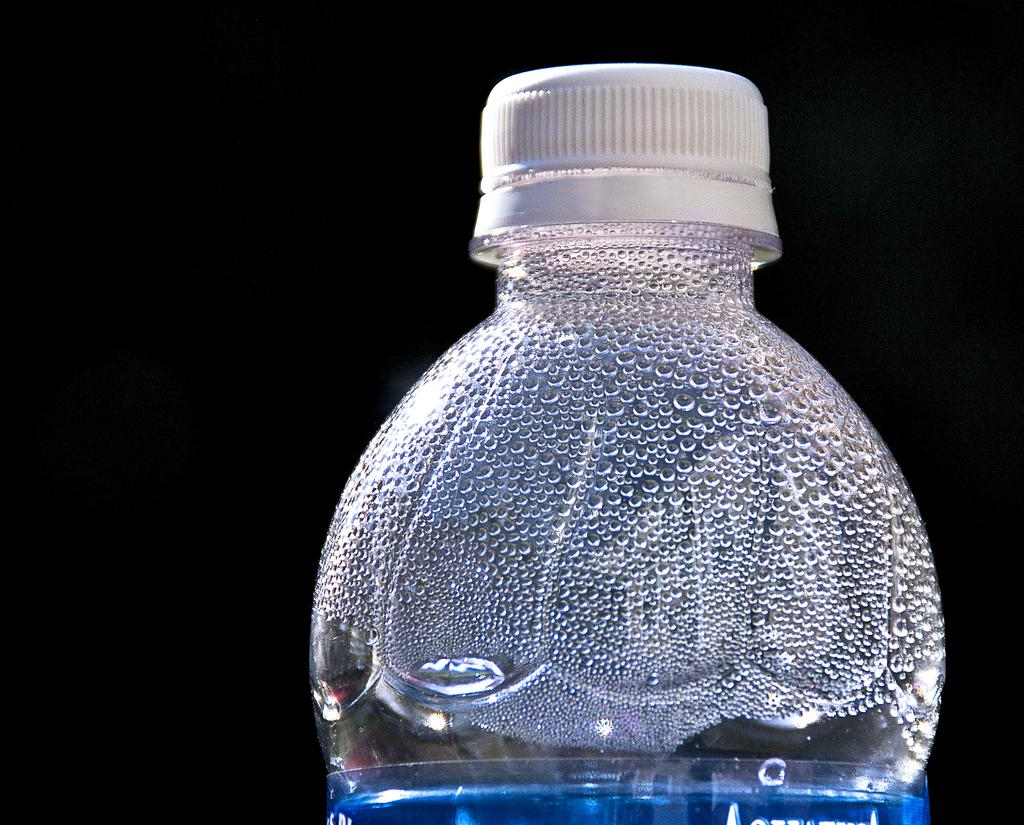What object can be seen in the picture? There is a water bottle in the picture. What color is the cap of the water bottle? The water bottle has a white cap. Are there any visible signs of moisture on the water bottle? Yes, there are water droplets on the side of the water bottle. What is the color of the background in the image? The background of the image is black. How many geese are flying over the train in the image? There is no train or geese present in the image; it only features a water bottle with a black background. 